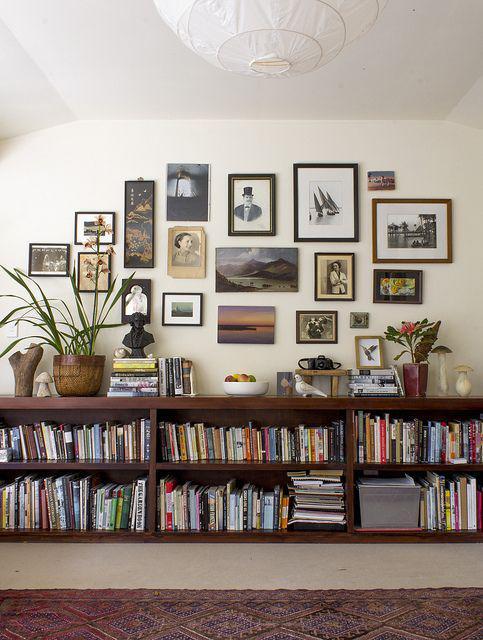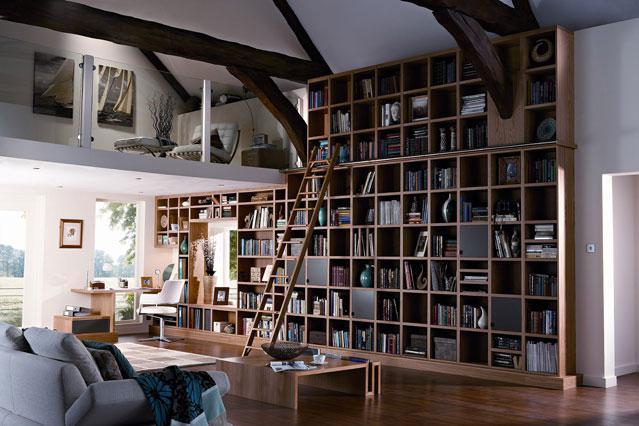The first image is the image on the left, the second image is the image on the right. Considering the images on both sides, is "One image includes a ladder leaning on a wall of bookshelves in a room with a wood floor and a pale rug." valid? Answer yes or no. Yes. The first image is the image on the left, the second image is the image on the right. Assess this claim about the two images: "In the left image there is a ladder leaning against the bookcase.". Correct or not? Answer yes or no. No. 